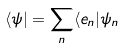<formula> <loc_0><loc_0><loc_500><loc_500>\langle \psi | = \sum _ { n } \langle e _ { n } | \psi _ { n }</formula> 